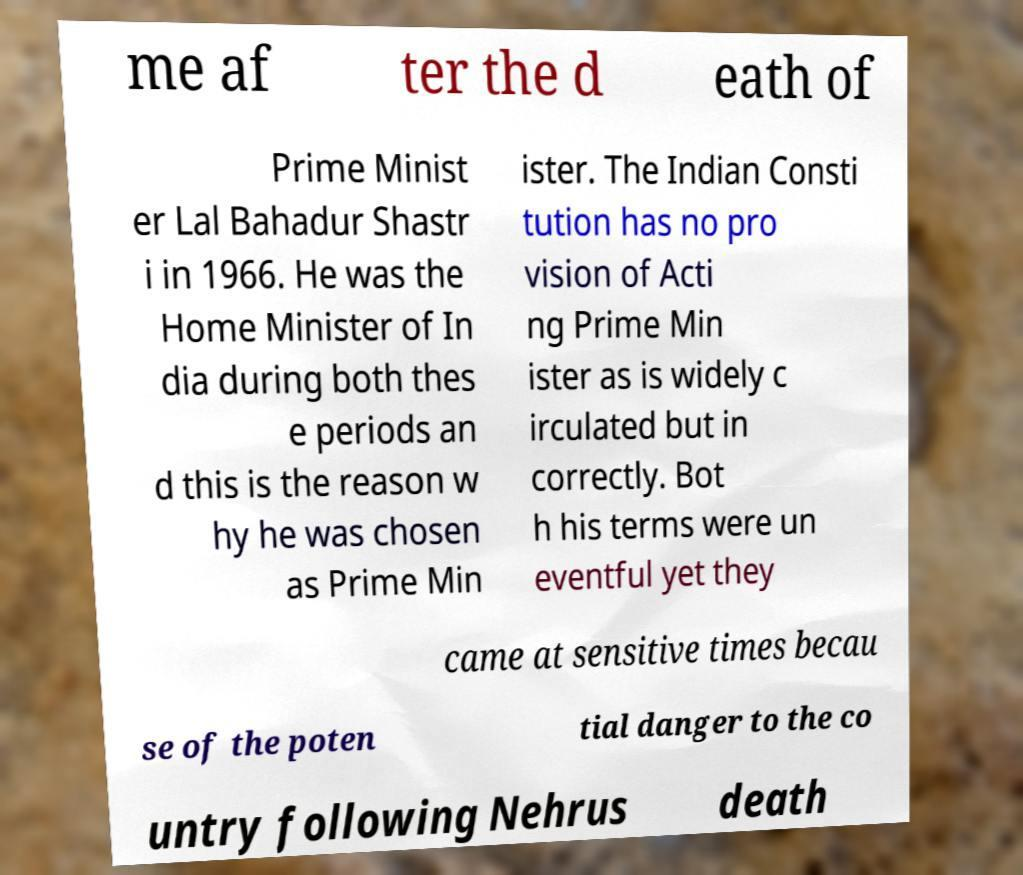Please read and relay the text visible in this image. What does it say? me af ter the d eath of Prime Minist er Lal Bahadur Shastr i in 1966. He was the Home Minister of In dia during both thes e periods an d this is the reason w hy he was chosen as Prime Min ister. The Indian Consti tution has no pro vision of Acti ng Prime Min ister as is widely c irculated but in correctly. Bot h his terms were un eventful yet they came at sensitive times becau se of the poten tial danger to the co untry following Nehrus death 